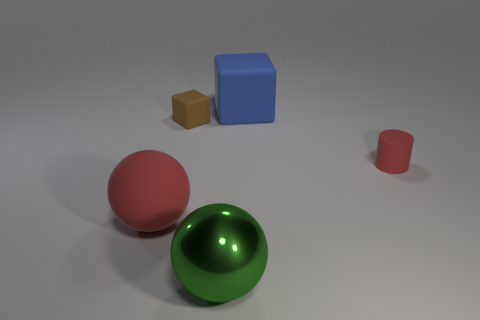Is there any indication of size or scale in this image? Absent any familiar objects or reference points, the scale and size of the objects in the image are ambiguous. The relative sizes of the objects to each other provide some sense of proportion, but without additional context, it's challenging to determine their actual dimensions. 